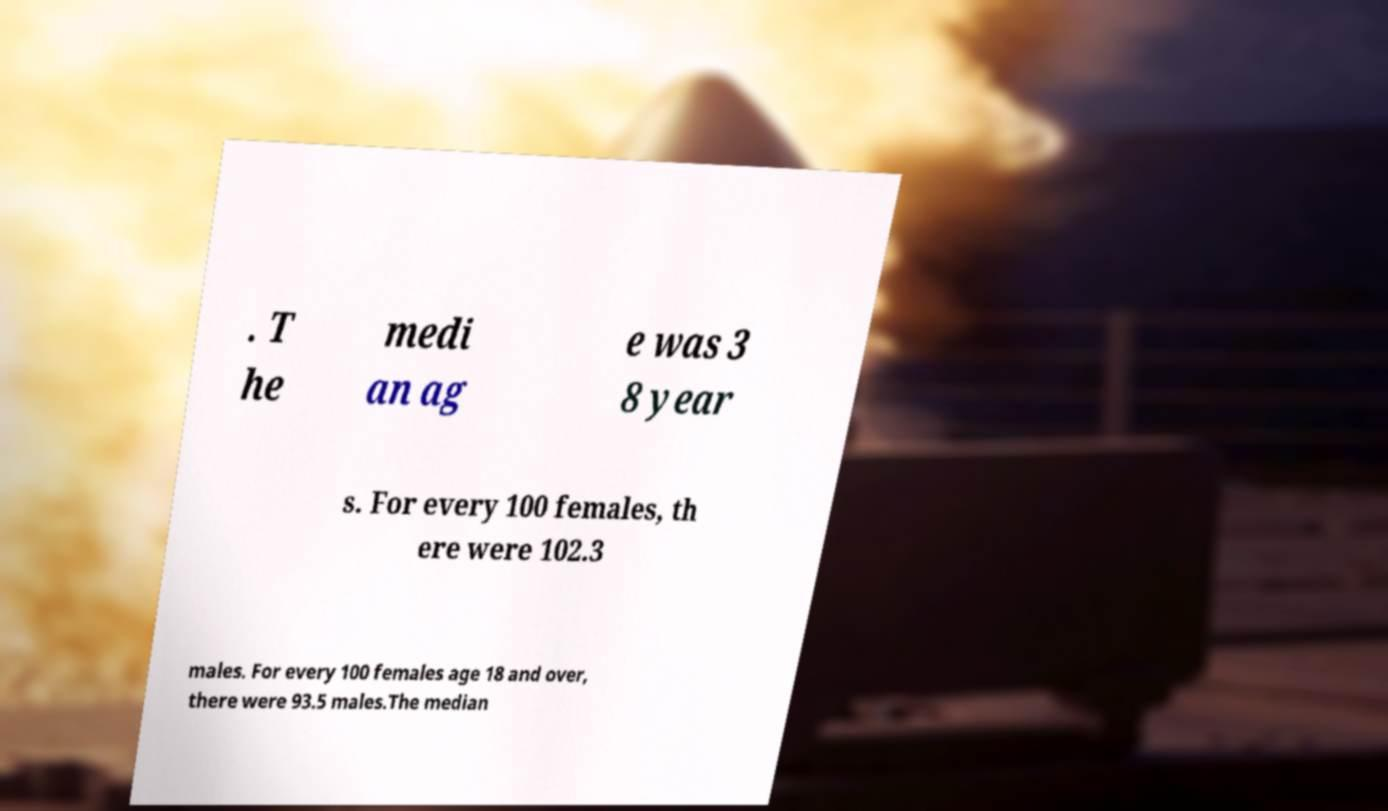Could you extract and type out the text from this image? . T he medi an ag e was 3 8 year s. For every 100 females, th ere were 102.3 males. For every 100 females age 18 and over, there were 93.5 males.The median 